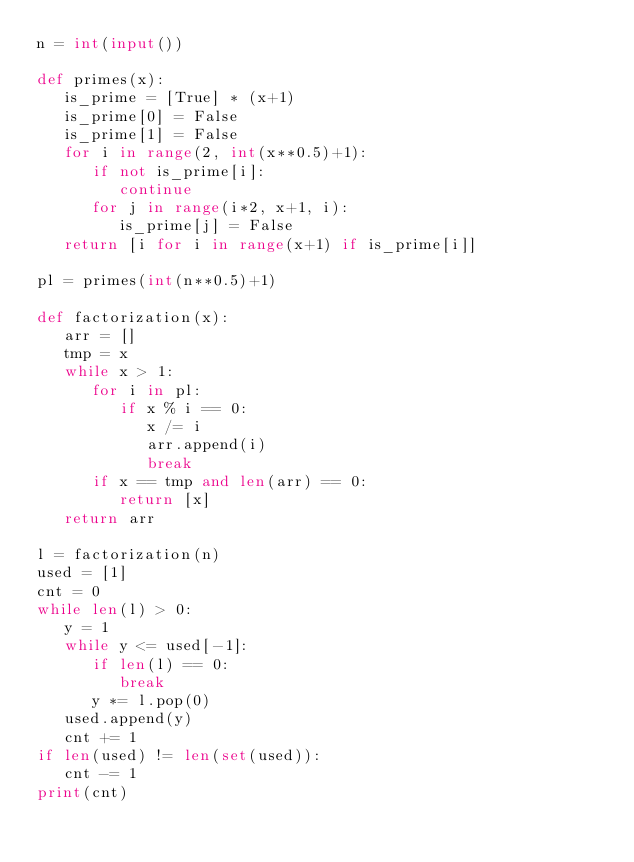Convert code to text. <code><loc_0><loc_0><loc_500><loc_500><_Python_>n = int(input())

def primes(x):
   is_prime = [True] * (x+1)
   is_prime[0] = False
   is_prime[1] = False
   for i in range(2, int(x**0.5)+1):
      if not is_prime[i]:
         continue
      for j in range(i*2, x+1, i):
         is_prime[j] = False
   return [i for i in range(x+1) if is_prime[i]]

pl = primes(int(n**0.5)+1)

def factorization(x):
   arr = []
   tmp = x
   while x > 1:
      for i in pl:
         if x % i == 0:
            x /= i
            arr.append(i)
            break
      if x == tmp and len(arr) == 0:
         return [x]
   return arr

l = factorization(n)
used = [1]
cnt = 0
while len(l) > 0:
   y = 1
   while y <= used[-1]:
      if len(l) == 0:
         break
      y *= l.pop(0)
   used.append(y)
   cnt += 1
if len(used) != len(set(used)):
   cnt -= 1
print(cnt)
</code> 